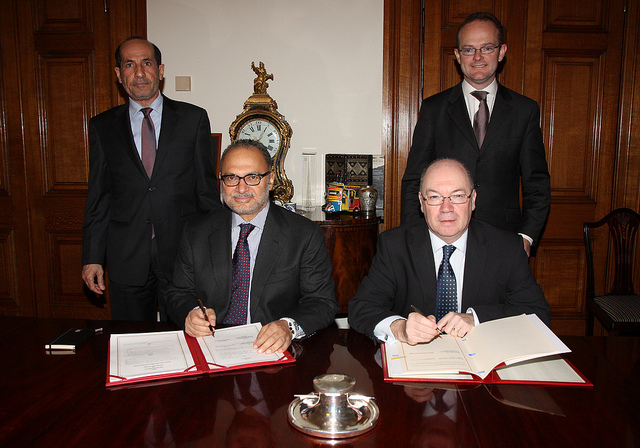What are the possible reasons for the two men in the foreground to be signing documents? The two men signing documents in the image are likely engaging in a formal agreement or contract signing. This could be indicative of a business deal, partnership, merger, or legal arrangement. The presence of witnesses or advisors standing behind them suggests that the documents are of significant importance, requiring verification or confirmation by multiple parties. 